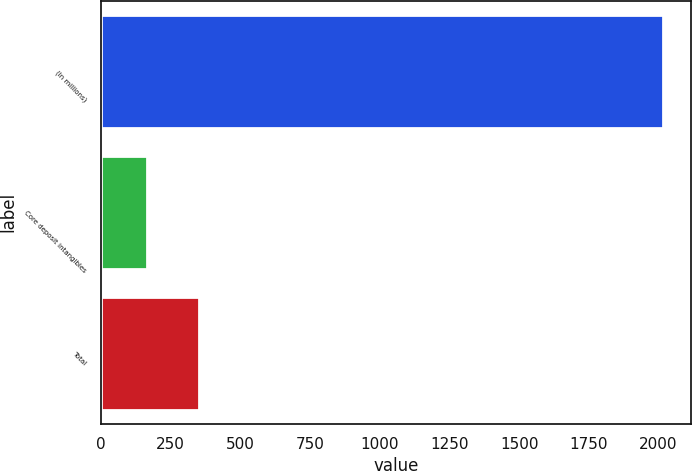Convert chart to OTSL. <chart><loc_0><loc_0><loc_500><loc_500><bar_chart><fcel>(In millions)<fcel>Core deposit intangibles<fcel>Total<nl><fcel>2017<fcel>167<fcel>352<nl></chart> 